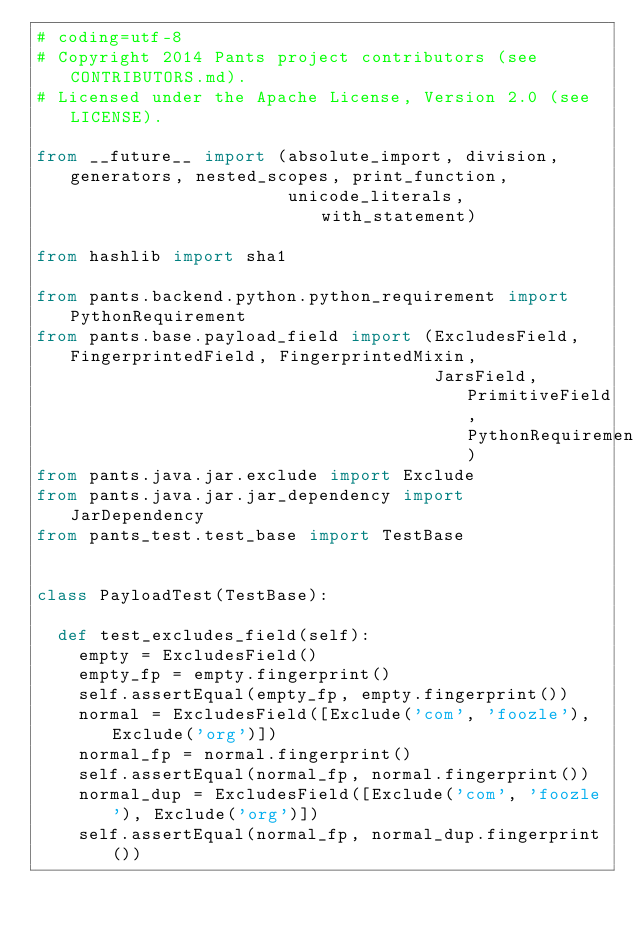<code> <loc_0><loc_0><loc_500><loc_500><_Python_># coding=utf-8
# Copyright 2014 Pants project contributors (see CONTRIBUTORS.md).
# Licensed under the Apache License, Version 2.0 (see LICENSE).

from __future__ import (absolute_import, division, generators, nested_scopes, print_function,
                        unicode_literals, with_statement)

from hashlib import sha1

from pants.backend.python.python_requirement import PythonRequirement
from pants.base.payload_field import (ExcludesField, FingerprintedField, FingerprintedMixin,
                                      JarsField, PrimitiveField, PythonRequirementsField)
from pants.java.jar.exclude import Exclude
from pants.java.jar.jar_dependency import JarDependency
from pants_test.test_base import TestBase


class PayloadTest(TestBase):

  def test_excludes_field(self):
    empty = ExcludesField()
    empty_fp = empty.fingerprint()
    self.assertEqual(empty_fp, empty.fingerprint())
    normal = ExcludesField([Exclude('com', 'foozle'), Exclude('org')])
    normal_fp = normal.fingerprint()
    self.assertEqual(normal_fp, normal.fingerprint())
    normal_dup = ExcludesField([Exclude('com', 'foozle'), Exclude('org')])
    self.assertEqual(normal_fp, normal_dup.fingerprint())</code> 